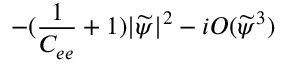Convert formula to latex. <formula><loc_0><loc_0><loc_500><loc_500>- ( \frac { 1 } { C _ { e e } } + 1 ) | \widetilde { \psi } | ^ { 2 } - i O ( \widetilde { \psi } ^ { 3 } )</formula> 